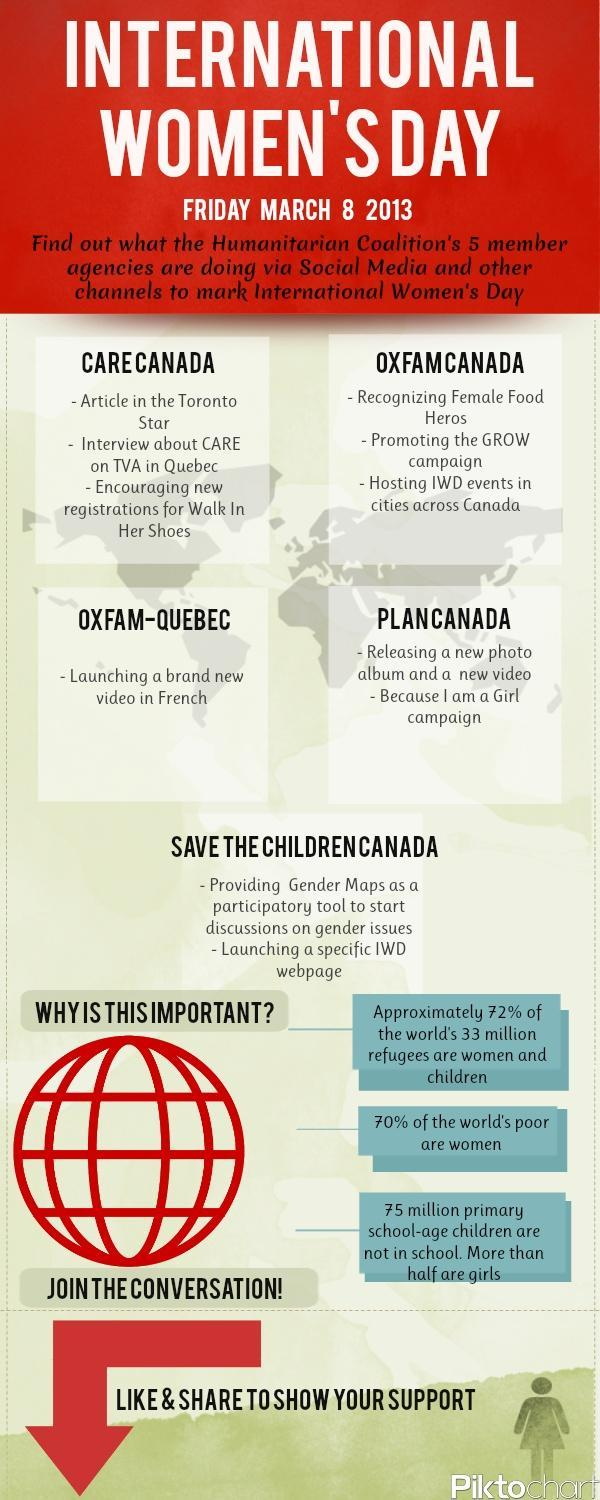Which agency is hosting IWD events in cities across Canada?
Answer the question with a short phrase. OXFAM Canada Who is launching a specific International Women's Day webpage? Save The Children Canada Which agency is releasing a new photo album and new video? Plan Canada Which agency is encouraging new registrations for Walk In Her Shoes? CARE CANADA Which agency is promoting the GROW campaign? OXFAM CANADA What is OXFAM-Quebec doing to mark International Women's Day? Launching a brand new video in French Who is recognizing Female Food Heros? OXFAM Canada Which agency is doing an interview about CARE on TVA in Quebec? CARE CANADA Which agency is doing an article in the Toronto Star for International women's day? CARE CANADA Which campaign is promoted by Plan Canada for International Women's Day? Because I am a Girl campaign 